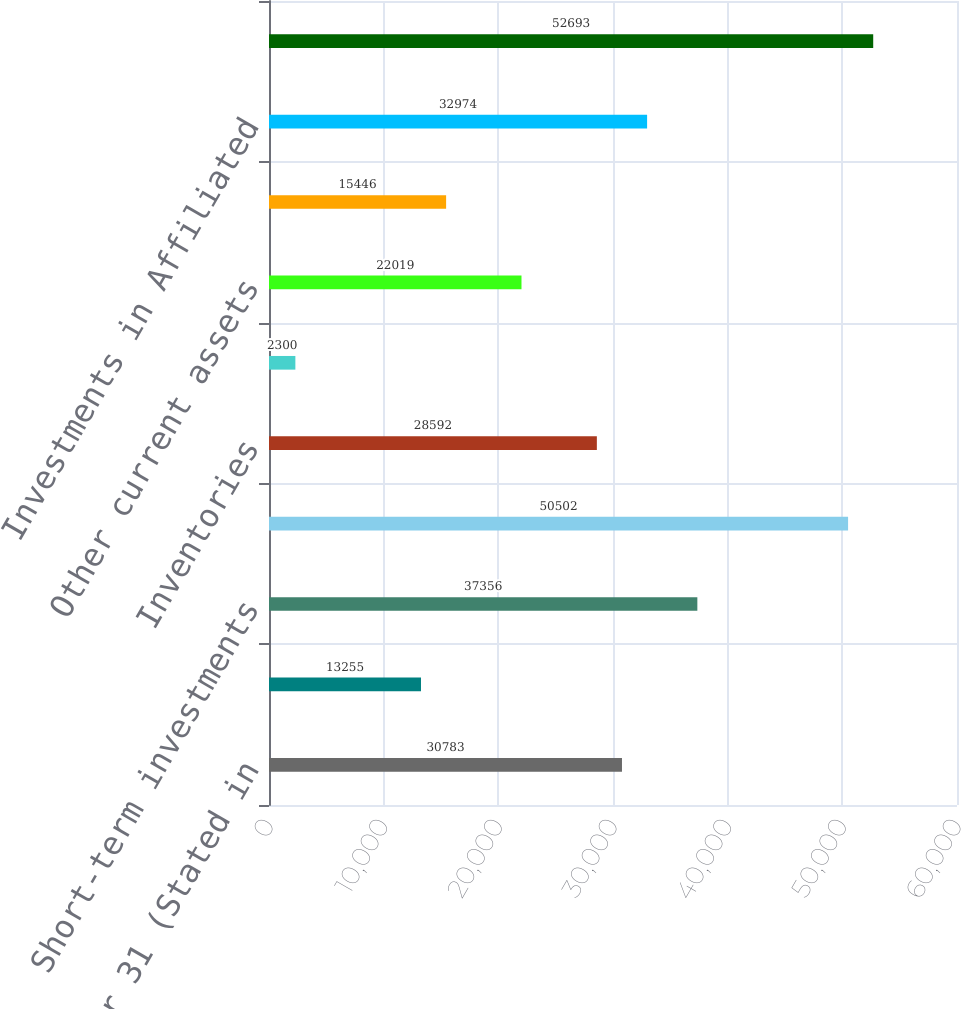Convert chart. <chart><loc_0><loc_0><loc_500><loc_500><bar_chart><fcel>December 31 (Stated in<fcel>Cash<fcel>Short-term investments<fcel>Receivables less allowance for<fcel>Inventories<fcel>Deferred taxes<fcel>Other current assets<fcel>Fixed Income Investments held<fcel>Investments in Affiliated<fcel>Fixed Assets less accumulated<nl><fcel>30783<fcel>13255<fcel>37356<fcel>50502<fcel>28592<fcel>2300<fcel>22019<fcel>15446<fcel>32974<fcel>52693<nl></chart> 